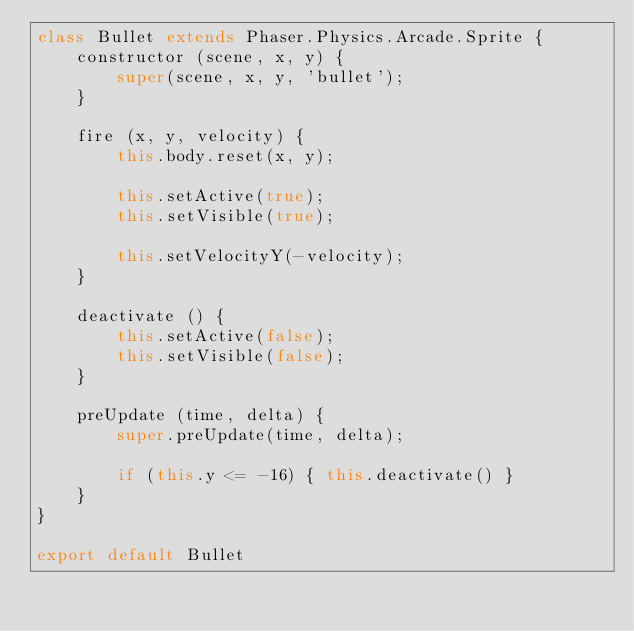Convert code to text. <code><loc_0><loc_0><loc_500><loc_500><_JavaScript_>class Bullet extends Phaser.Physics.Arcade.Sprite {
    constructor (scene, x, y) {
        super(scene, x, y, 'bullet');
    }

    fire (x, y, velocity) {
        this.body.reset(x, y);

        this.setActive(true);
        this.setVisible(true);

        this.setVelocityY(-velocity);
    }

    deactivate () {
        this.setActive(false);
        this.setVisible(false);
    }

    preUpdate (time, delta) {
        super.preUpdate(time, delta);

        if (this.y <= -16) { this.deactivate() }
    }
}

export default Bullet</code> 